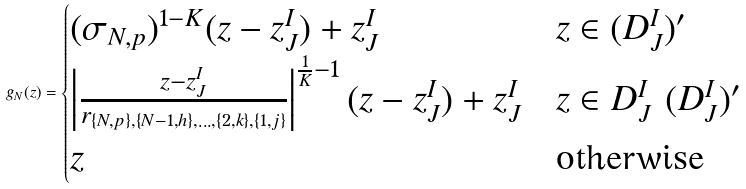Convert formula to latex. <formula><loc_0><loc_0><loc_500><loc_500>g _ { N } ( z ) = \begin{cases} ( \sigma _ { N , p } ) ^ { 1 - K } ( z - z ^ { I } _ { J } ) + z ^ { I } _ { J } & z \in ( D ^ { I } _ { J } ) ^ { \prime } \\ \left | \frac { z - z ^ { I } _ { J } } { r _ { \{ N , p \} , \{ N - 1 , h \} , \dots , \{ 2 , k \} , \{ 1 , j \} } } \right | ^ { \frac { 1 } { K } - 1 } ( z - z ^ { I } _ { J } ) + z ^ { I } _ { J } & z \in D ^ { I } _ { J } \ ( D ^ { I } _ { J } ) ^ { \prime } \\ z & \text {otherwise} \end{cases}</formula> 